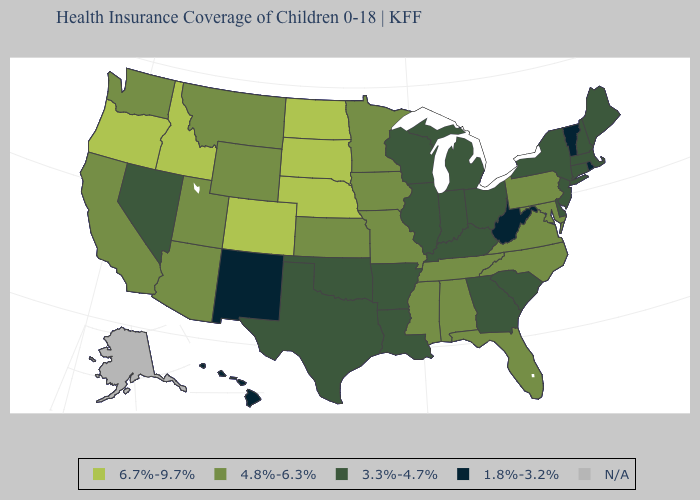What is the value of Ohio?
Give a very brief answer. 3.3%-4.7%. What is the lowest value in the USA?
Answer briefly. 1.8%-3.2%. What is the highest value in the USA?
Write a very short answer. 6.7%-9.7%. Does the first symbol in the legend represent the smallest category?
Short answer required. No. What is the highest value in states that border Arkansas?
Give a very brief answer. 4.8%-6.3%. Name the states that have a value in the range N/A?
Keep it brief. Alaska. Name the states that have a value in the range 4.8%-6.3%?
Concise answer only. Alabama, Arizona, California, Florida, Iowa, Kansas, Maryland, Minnesota, Mississippi, Missouri, Montana, North Carolina, Pennsylvania, Tennessee, Utah, Virginia, Washington, Wyoming. What is the highest value in the USA?
Give a very brief answer. 6.7%-9.7%. Which states hav the highest value in the South?
Be succinct. Alabama, Florida, Maryland, Mississippi, North Carolina, Tennessee, Virginia. Name the states that have a value in the range 1.8%-3.2%?
Concise answer only. Hawaii, New Mexico, Rhode Island, Vermont, West Virginia. How many symbols are there in the legend?
Quick response, please. 5. Among the states that border Minnesota , does South Dakota have the highest value?
Quick response, please. Yes. Does North Carolina have the highest value in the South?
Keep it brief. Yes. 